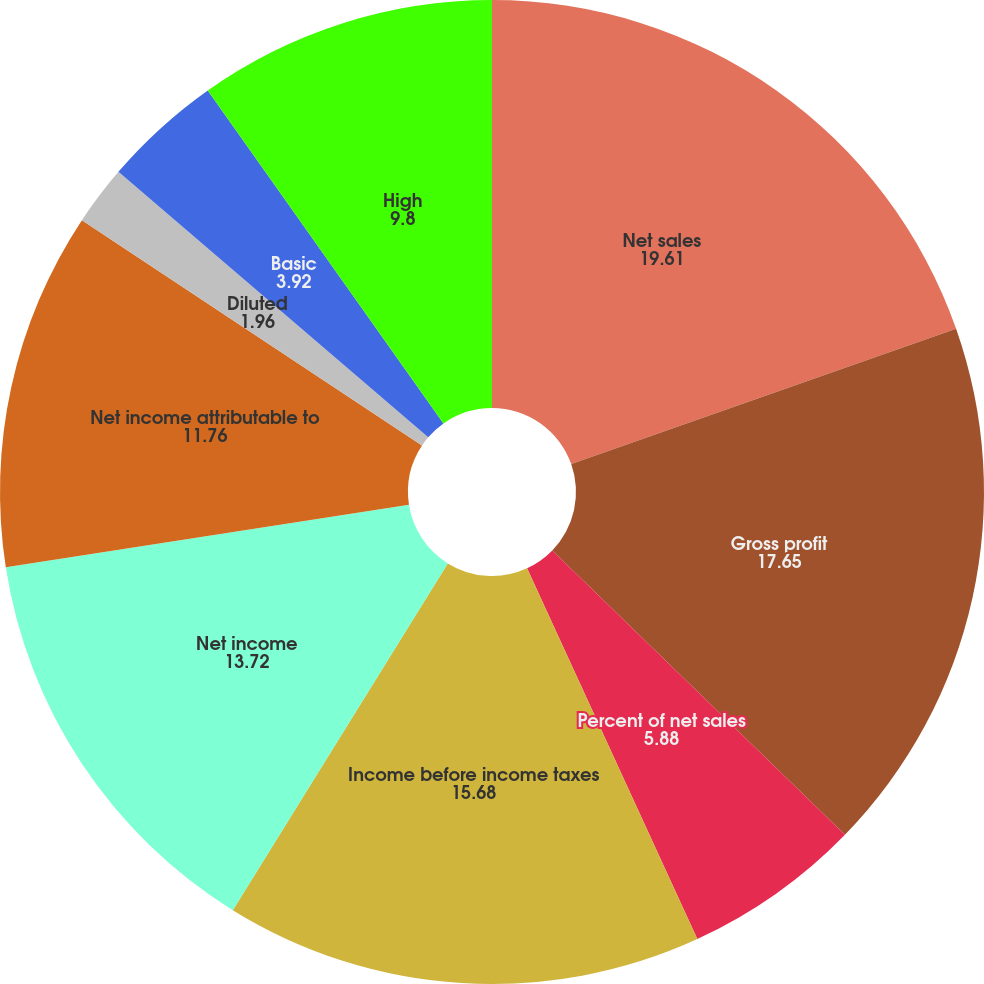<chart> <loc_0><loc_0><loc_500><loc_500><pie_chart><fcel>Net sales<fcel>Gross profit<fcel>Percent of net sales<fcel>Income before income taxes<fcel>Net income<fcel>Net income attributable to<fcel>Diluted<fcel>Basic<fcel>Cash dividends declared per<fcel>High<nl><fcel>19.61%<fcel>17.65%<fcel>5.88%<fcel>15.68%<fcel>13.72%<fcel>11.76%<fcel>1.96%<fcel>3.92%<fcel>0.0%<fcel>9.8%<nl></chart> 